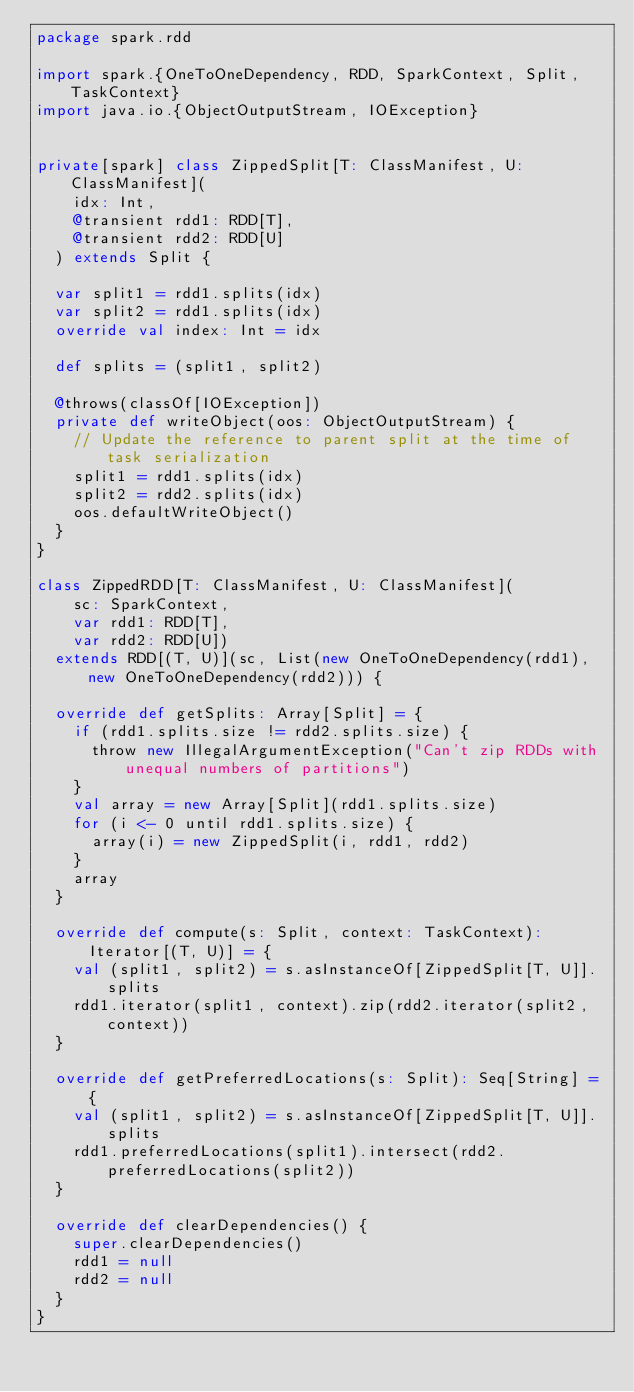Convert code to text. <code><loc_0><loc_0><loc_500><loc_500><_Scala_>package spark.rdd

import spark.{OneToOneDependency, RDD, SparkContext, Split, TaskContext}
import java.io.{ObjectOutputStream, IOException}


private[spark] class ZippedSplit[T: ClassManifest, U: ClassManifest](
    idx: Int,
    @transient rdd1: RDD[T],
    @transient rdd2: RDD[U]
  ) extends Split {

  var split1 = rdd1.splits(idx)
  var split2 = rdd1.splits(idx)
  override val index: Int = idx

  def splits = (split1, split2)

  @throws(classOf[IOException])
  private def writeObject(oos: ObjectOutputStream) {
    // Update the reference to parent split at the time of task serialization
    split1 = rdd1.splits(idx)
    split2 = rdd2.splits(idx)
    oos.defaultWriteObject()
  }
}

class ZippedRDD[T: ClassManifest, U: ClassManifest](
    sc: SparkContext,
    var rdd1: RDD[T],
    var rdd2: RDD[U])
  extends RDD[(T, U)](sc, List(new OneToOneDependency(rdd1), new OneToOneDependency(rdd2))) {

  override def getSplits: Array[Split] = {
    if (rdd1.splits.size != rdd2.splits.size) {
      throw new IllegalArgumentException("Can't zip RDDs with unequal numbers of partitions")
    }
    val array = new Array[Split](rdd1.splits.size)
    for (i <- 0 until rdd1.splits.size) {
      array(i) = new ZippedSplit(i, rdd1, rdd2)
    }
    array
  }

  override def compute(s: Split, context: TaskContext): Iterator[(T, U)] = {
    val (split1, split2) = s.asInstanceOf[ZippedSplit[T, U]].splits
    rdd1.iterator(split1, context).zip(rdd2.iterator(split2, context))
  }

  override def getPreferredLocations(s: Split): Seq[String] = {
    val (split1, split2) = s.asInstanceOf[ZippedSplit[T, U]].splits
    rdd1.preferredLocations(split1).intersect(rdd2.preferredLocations(split2))
  }

  override def clearDependencies() {
    super.clearDependencies()
    rdd1 = null
    rdd2 = null
  }
}
</code> 